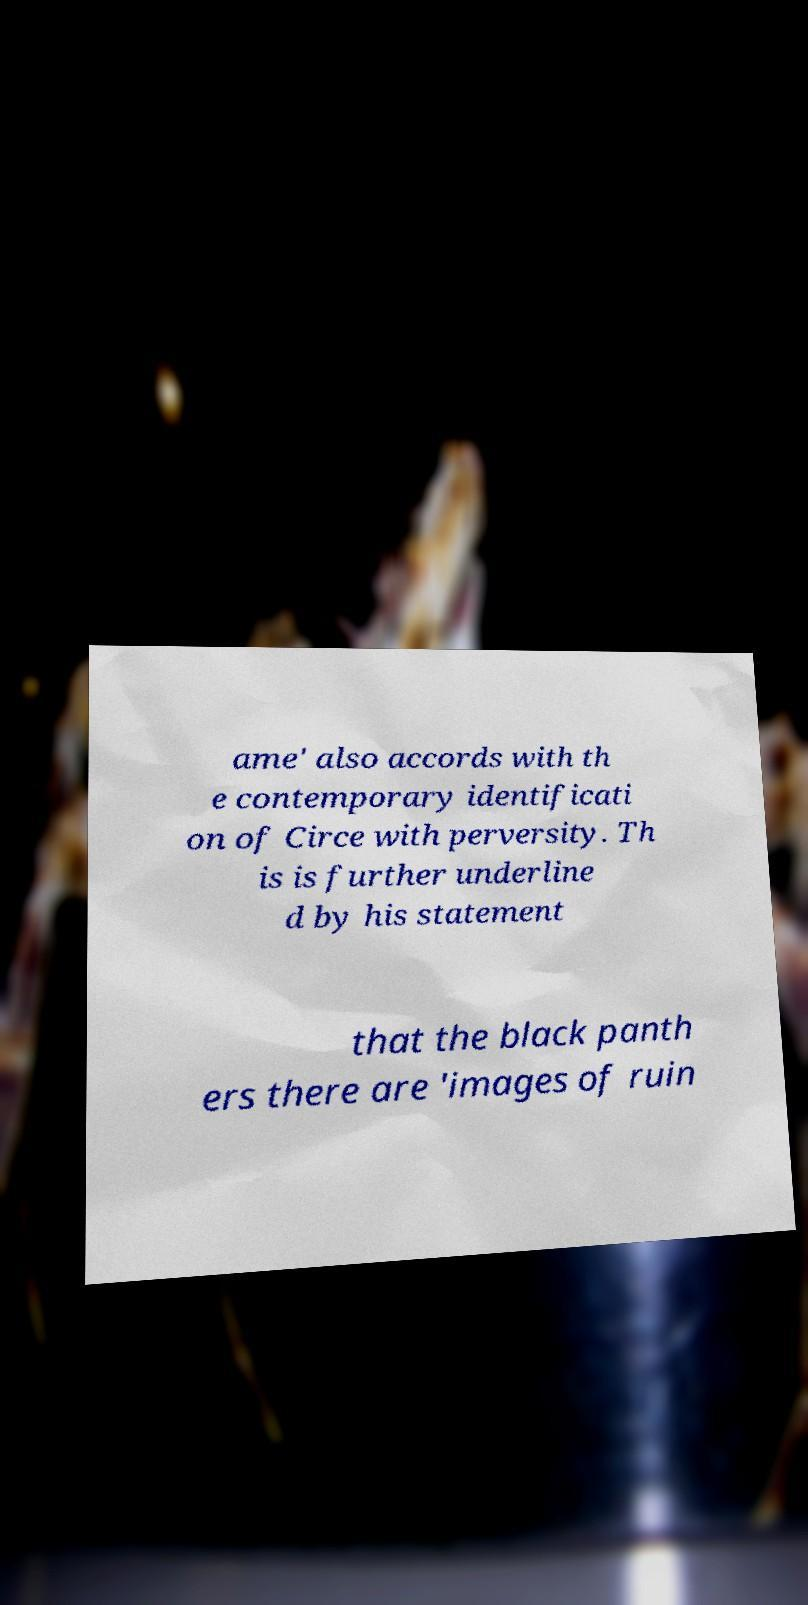Please identify and transcribe the text found in this image. ame' also accords with th e contemporary identificati on of Circe with perversity. Th is is further underline d by his statement that the black panth ers there are 'images of ruin 